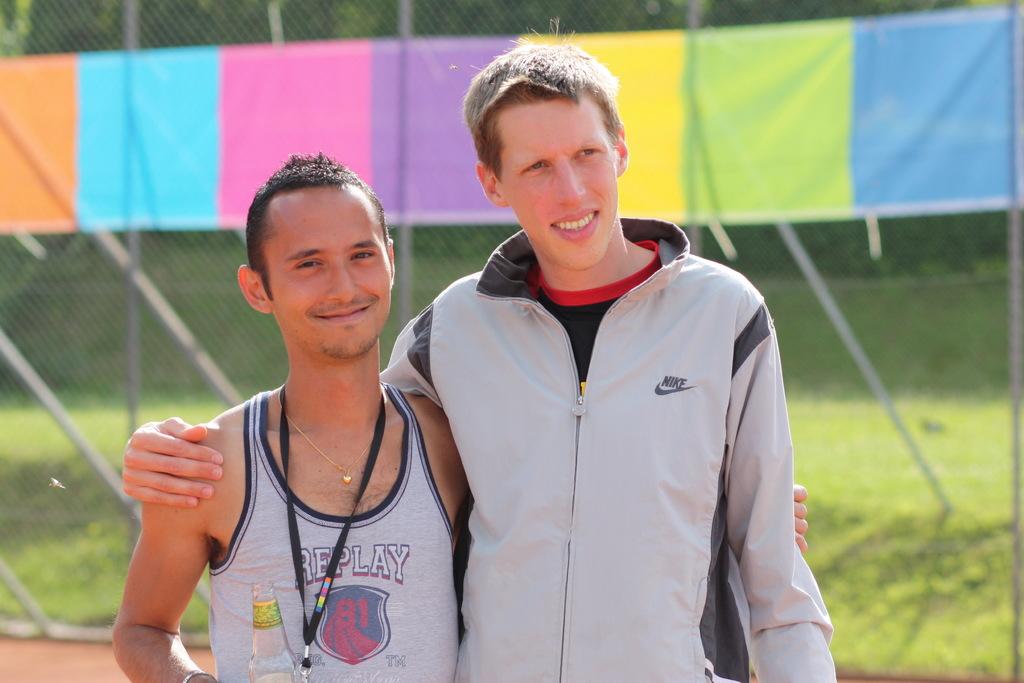What brand of clothing is the man wearing?
Ensure brevity in your answer.  Nike. What does the man's shirt say on the left?
Your answer should be very brief. Replay. 